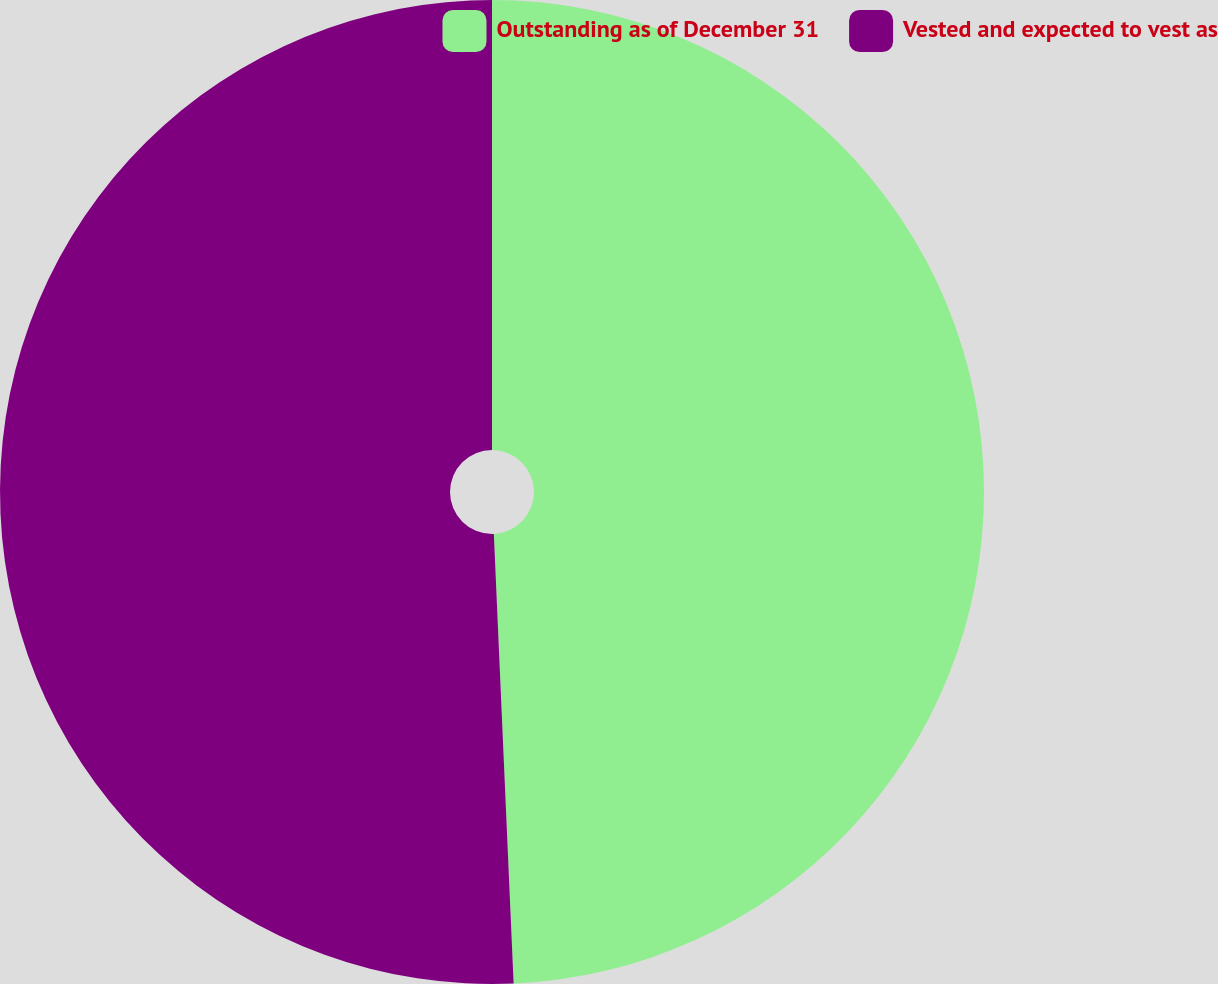Convert chart to OTSL. <chart><loc_0><loc_0><loc_500><loc_500><pie_chart><fcel>Outstanding as of December 31<fcel>Vested and expected to vest as<nl><fcel>49.3%<fcel>50.7%<nl></chart> 